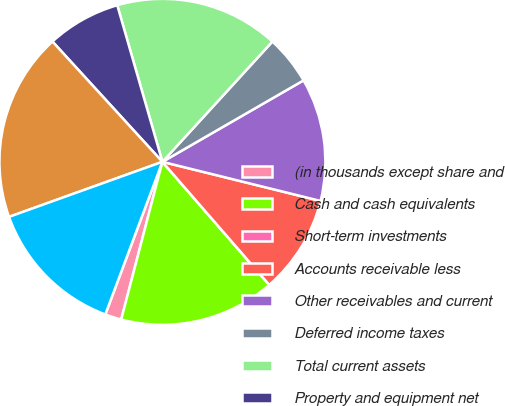Convert chart to OTSL. <chart><loc_0><loc_0><loc_500><loc_500><pie_chart><fcel>(in thousands except share and<fcel>Cash and cash equivalents<fcel>Short-term investments<fcel>Accounts receivable less<fcel>Other receivables and current<fcel>Deferred income taxes<fcel>Total current assets<fcel>Property and equipment net<fcel>Goodwill<fcel>Other intangible assets net<nl><fcel>1.63%<fcel>15.45%<fcel>0.0%<fcel>9.76%<fcel>12.19%<fcel>4.88%<fcel>16.26%<fcel>7.32%<fcel>18.7%<fcel>13.82%<nl></chart> 